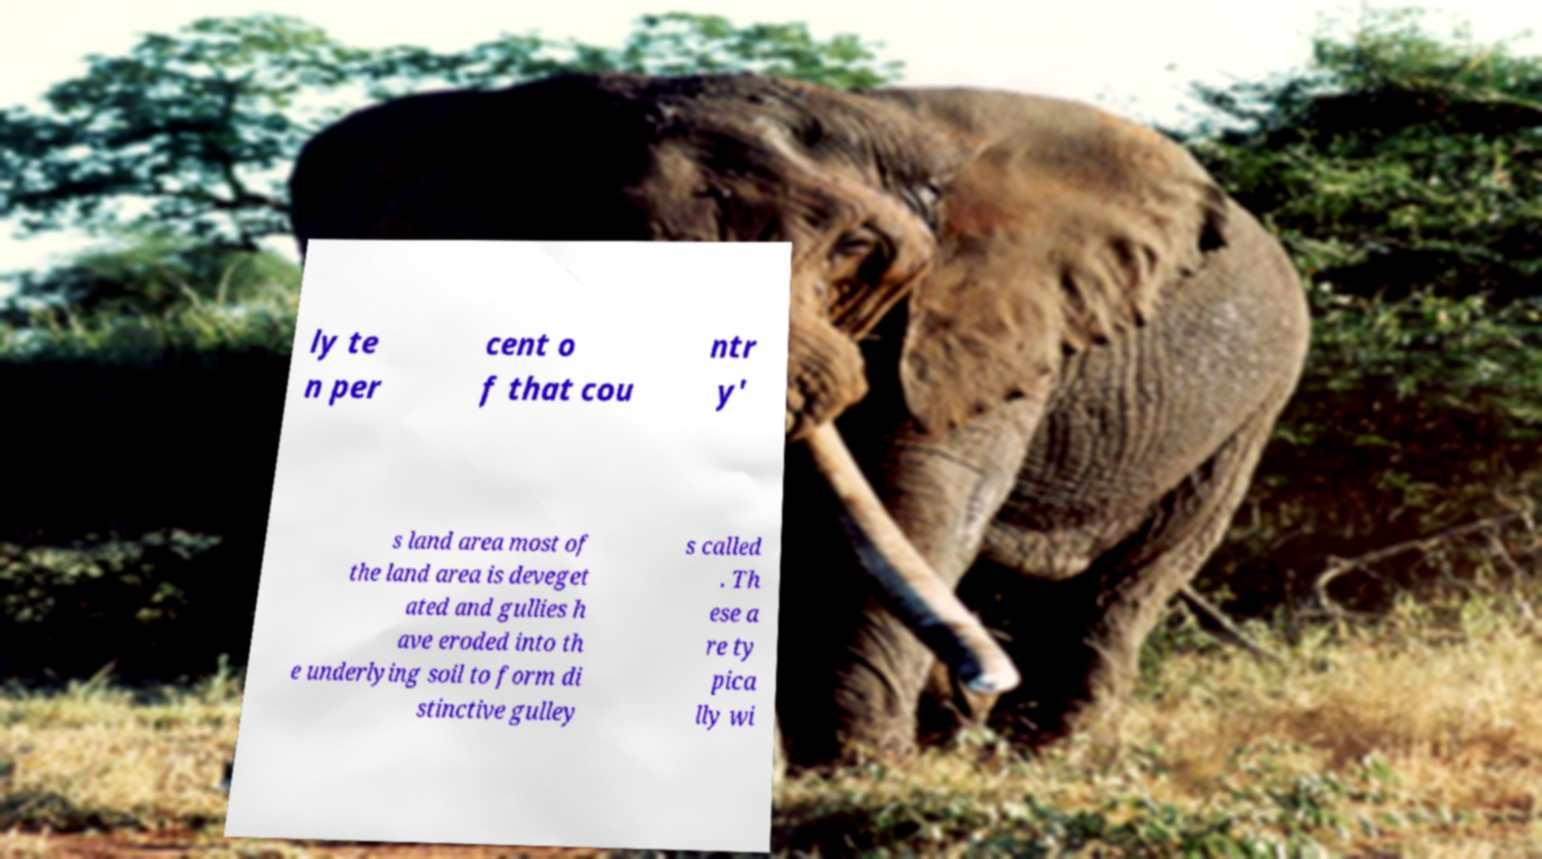Could you extract and type out the text from this image? ly te n per cent o f that cou ntr y' s land area most of the land area is deveget ated and gullies h ave eroded into th e underlying soil to form di stinctive gulley s called . Th ese a re ty pica lly wi 